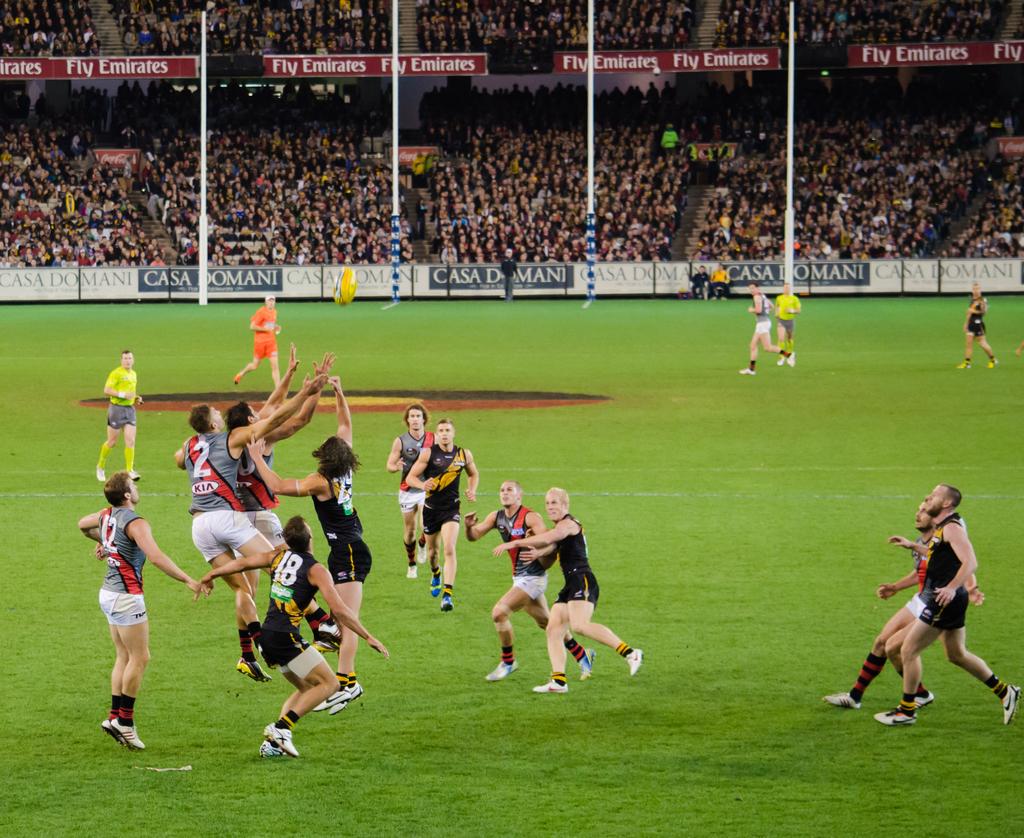What is the number of the red player near the referee?
Offer a very short reply. 2. Left players number?
Your answer should be compact. 12. 